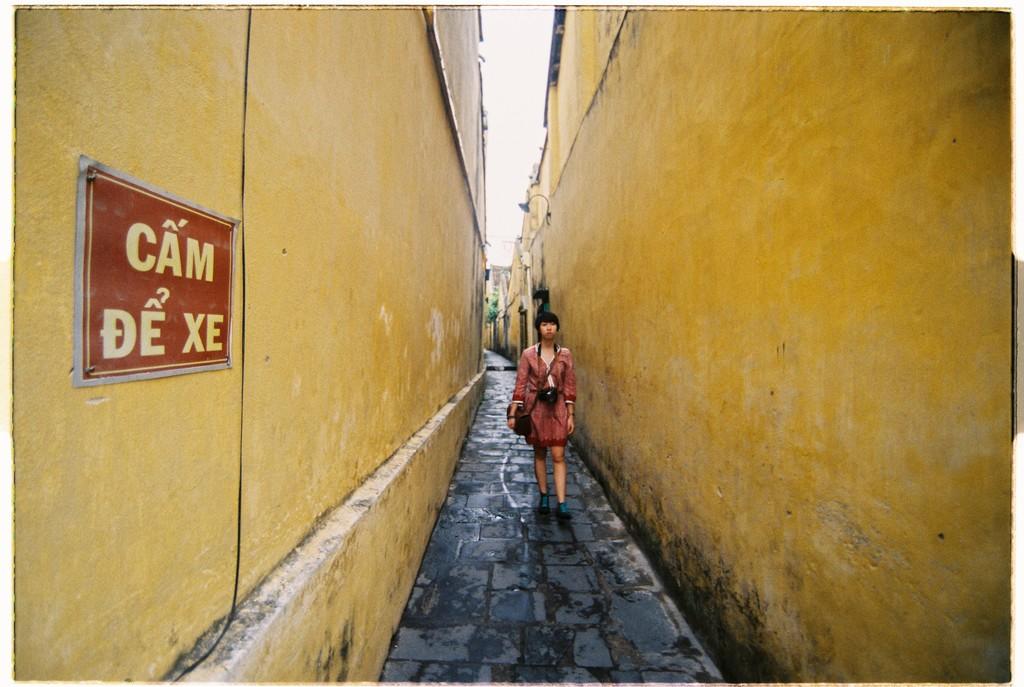What does the sign say?
Ensure brevity in your answer.  Cam de xe. 